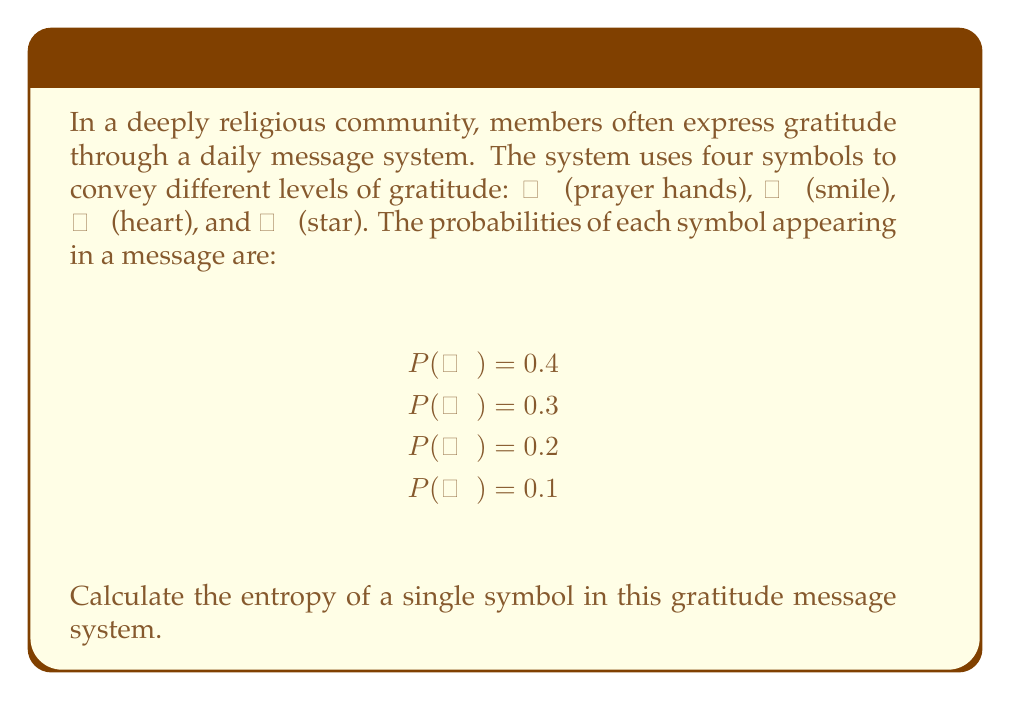Provide a solution to this math problem. To calculate the entropy of a single symbol in this message system, we'll use the formula for Shannon entropy:

$$H = -\sum_{i=1}^n p_i \log_2(p_i)$$

Where:
- $H$ is the entropy in bits
- $p_i$ is the probability of each symbol
- $n$ is the number of possible symbols (in this case, 4)

Let's calculate the entropy for each symbol:

1. For 🙏 (prayer hands):
   $-0.4 \log_2(0.4) = 0.528$ bits

2. For 😊 (smile):
   $-0.3 \log_2(0.3) = 0.521$ bits

3. For ❤️ (heart):
   $-0.2 \log_2(0.2) = 0.464$ bits

4. For 🌟 (star):
   $-0.1 \log_2(0.1) = 0.332$ bits

Now, we sum these values:

$$H = 0.528 + 0.521 + 0.464 + 0.332 = 1.845\text{ bits}$$

This result represents the average amount of information conveyed by a single symbol in the gratitude message system.
Answer: $1.845\text{ bits}$ 